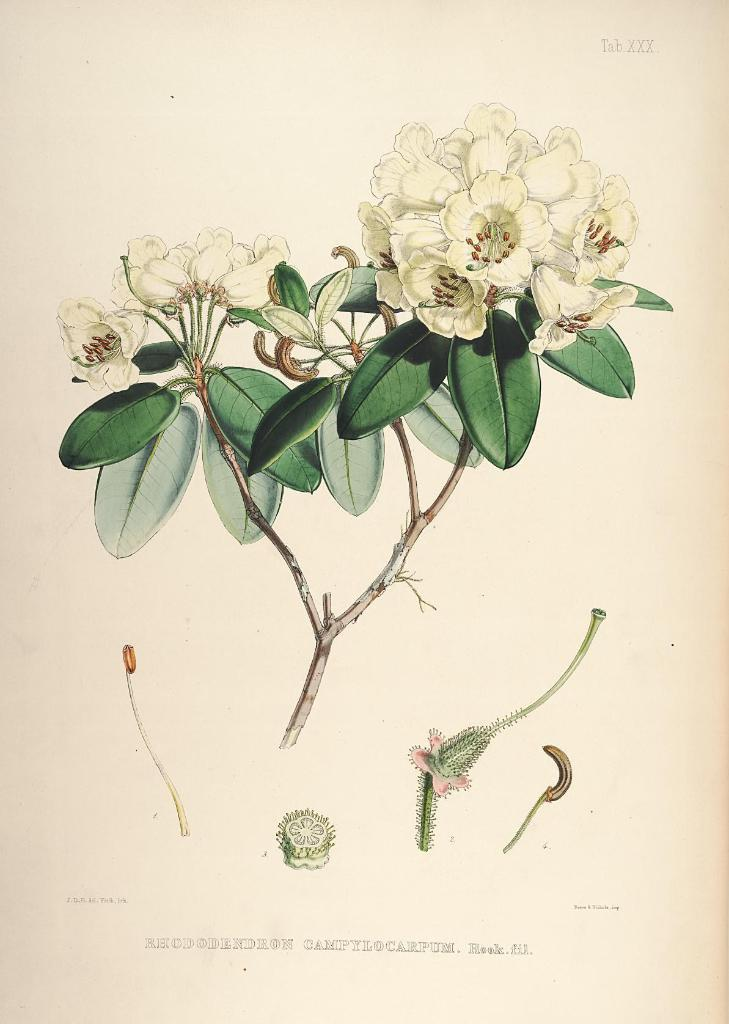What type of images are present in the picture? There are pictures of flowers in the image. What aspect of the flowers is depicted in the pictures? The pictures show the inner parts of the flowers. On what medium are the pictures displayed? The pictures are on a paper. How many bombs can be seen in the image? There are no bombs present in the image; it features pictures of flowers. What year is depicted in the image? The image does not depict a specific year; it shows pictures of flowers' inner parts on a paper. 